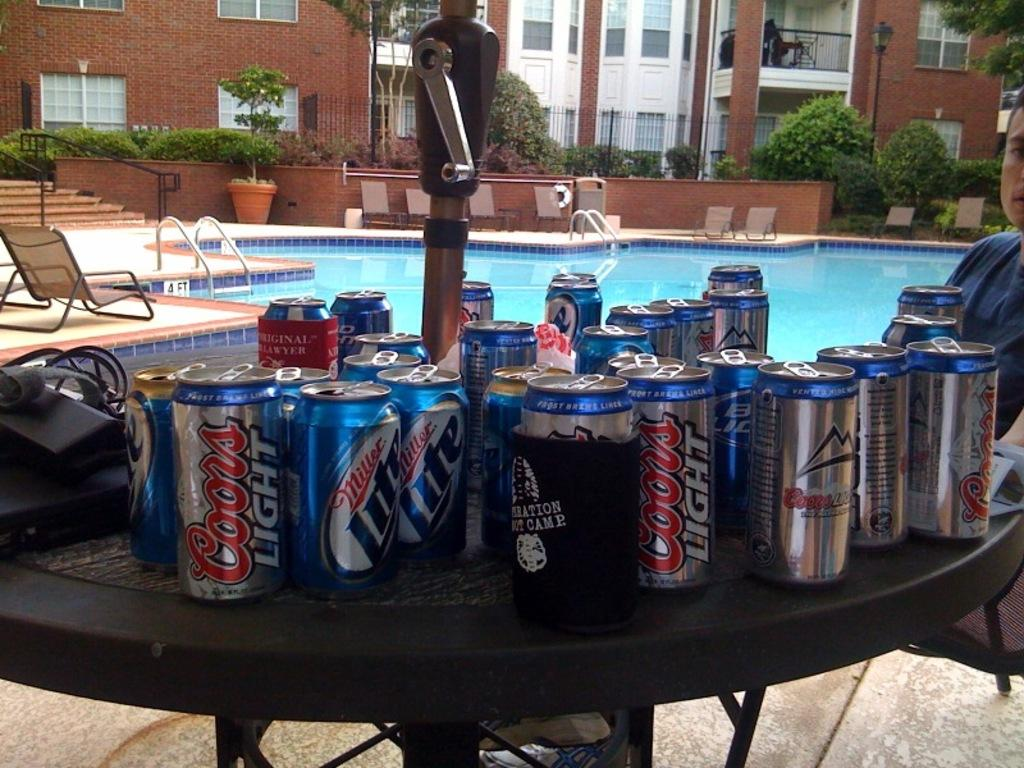<image>
Relay a brief, clear account of the picture shown. Coors Light and Miller Lite cans sit with each other on a patio table. 